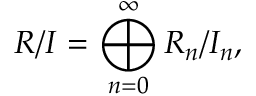Convert formula to latex. <formula><loc_0><loc_0><loc_500><loc_500>R / I = \bigoplus _ { n = 0 } ^ { \infty } R _ { n } / I _ { n } ,</formula> 